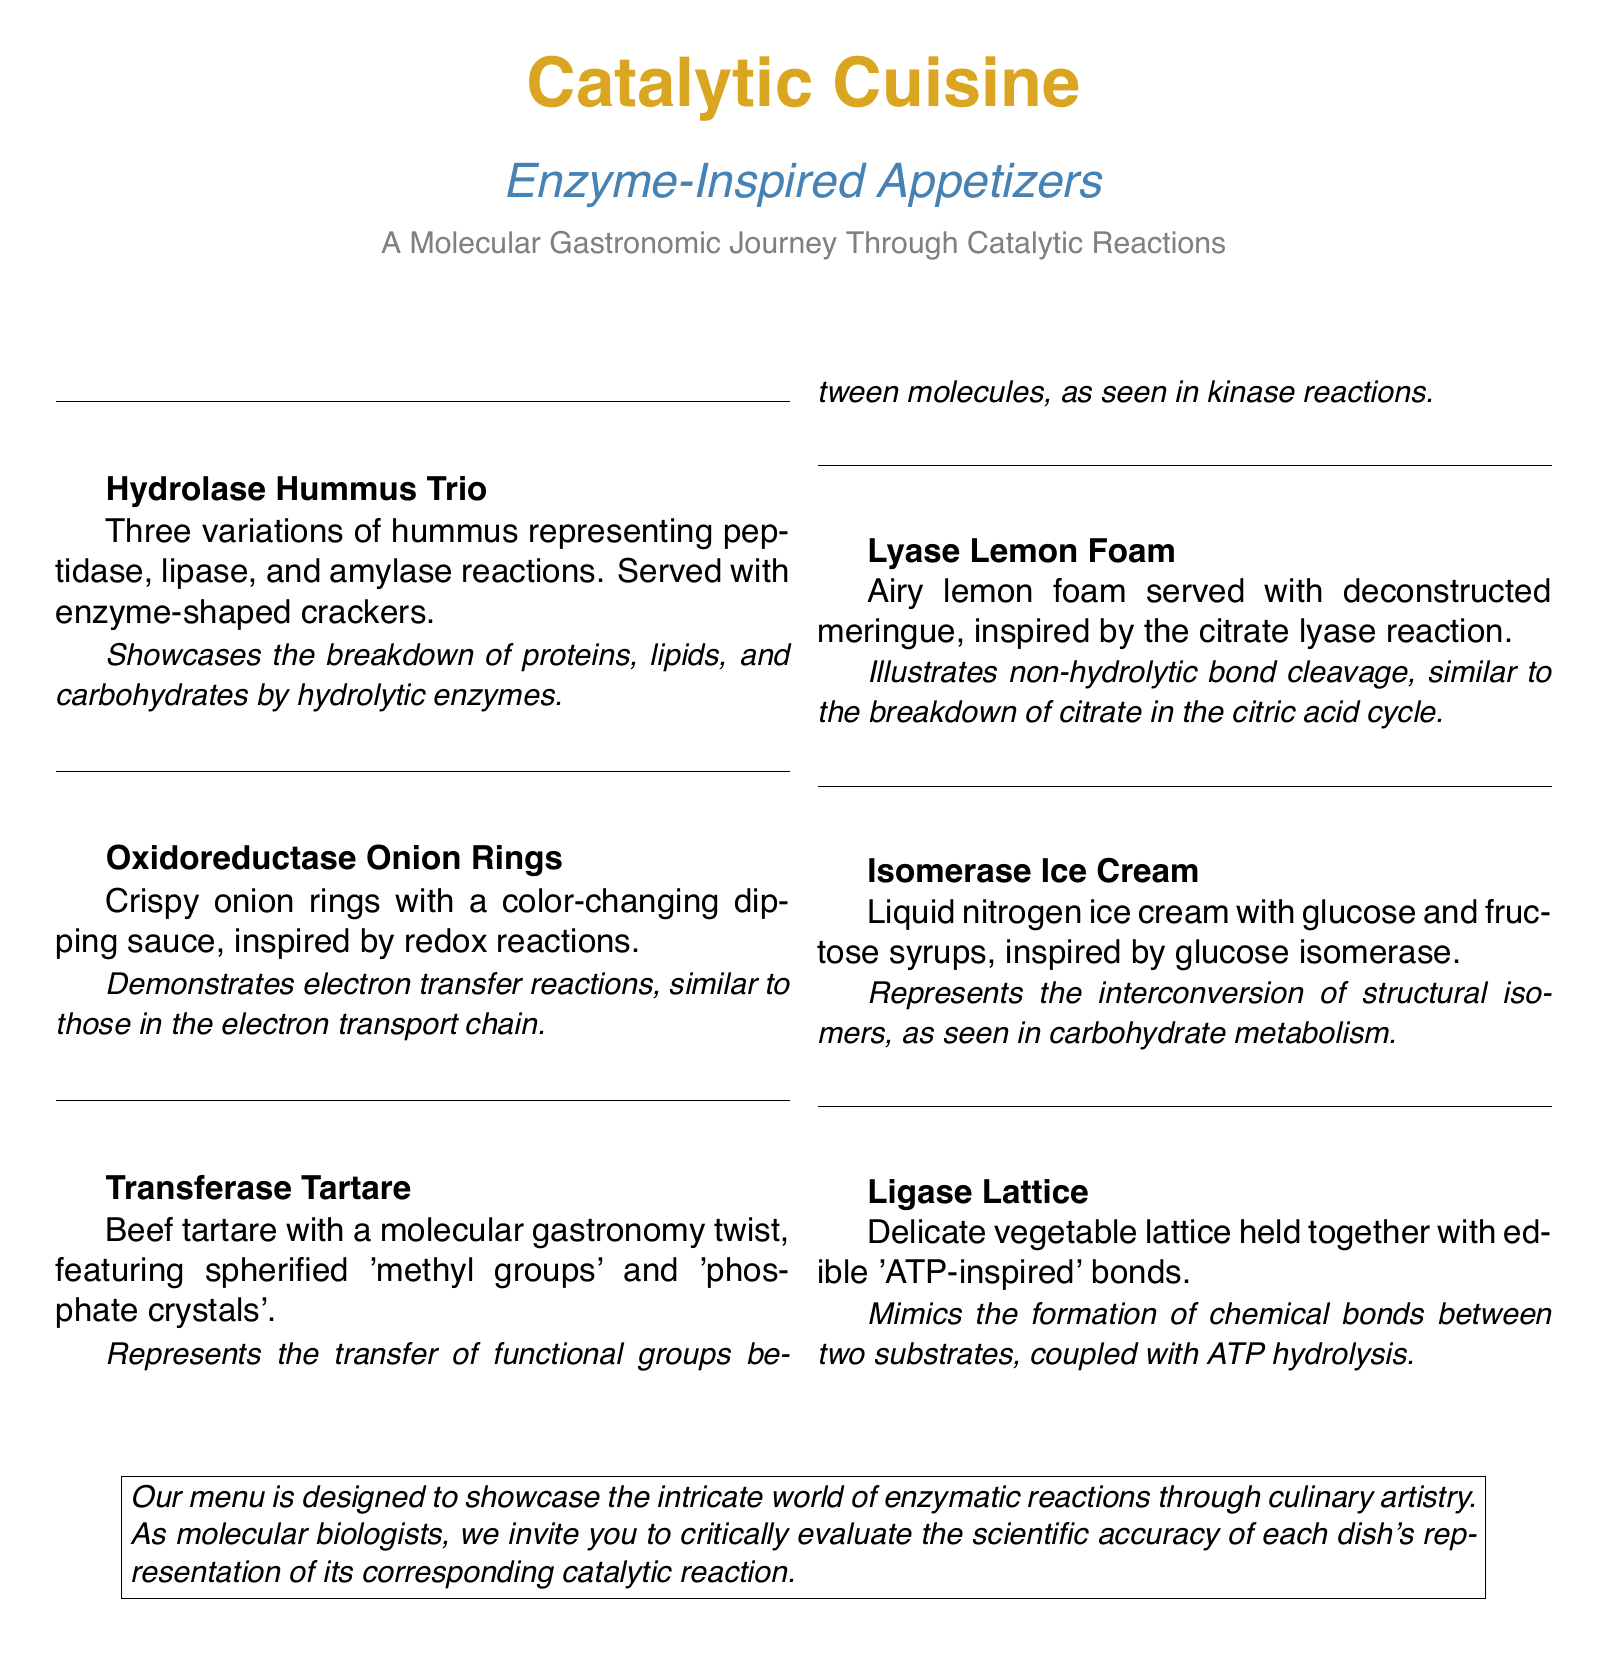What is the first dish listed on the menu? The first dish is "Hydrolase Hummus Trio," as it appears first in the document.
Answer: Hydrolase Hummus Trio How many variations of hummus are offered in the first dish? The first dish, "Hydrolase Hummus Trio," mentions three variations of hummus.
Answer: Three What type of cuisine is highlighted in the menu? The menu emphasizes a molecular gastronomic journey through catalytic reactions.
Answer: Catalytic Cuisine Which dish is inspired by the electron transport chain? The dish "Oxidoreductase Onion Rings" is inspired by redox reactions, similar to those in the electron transport chain.
Answer: Oxidoreductase Onion Rings What ingredient is used in the Transferase Tartare dish? The ingredient mentioned in the "Transferase Tartare" dish is beef, with a molecular twist including spherified 'methyl groups' and 'phosphate crystals'.
Answer: Beef tartare What culinary technique is represented by Isomerase Ice Cream? The "Isomerase Ice Cream" uses liquid nitrogen to create the dessert.
Answer: Liquid nitrogen What bonding concept is illustrated in the Ligase Lattice dish? The "Ligase Lattice" concept involves edible 'ATP-inspired' bonds that mimic chemical bond formation.
Answer: ATP-inspired bonds 